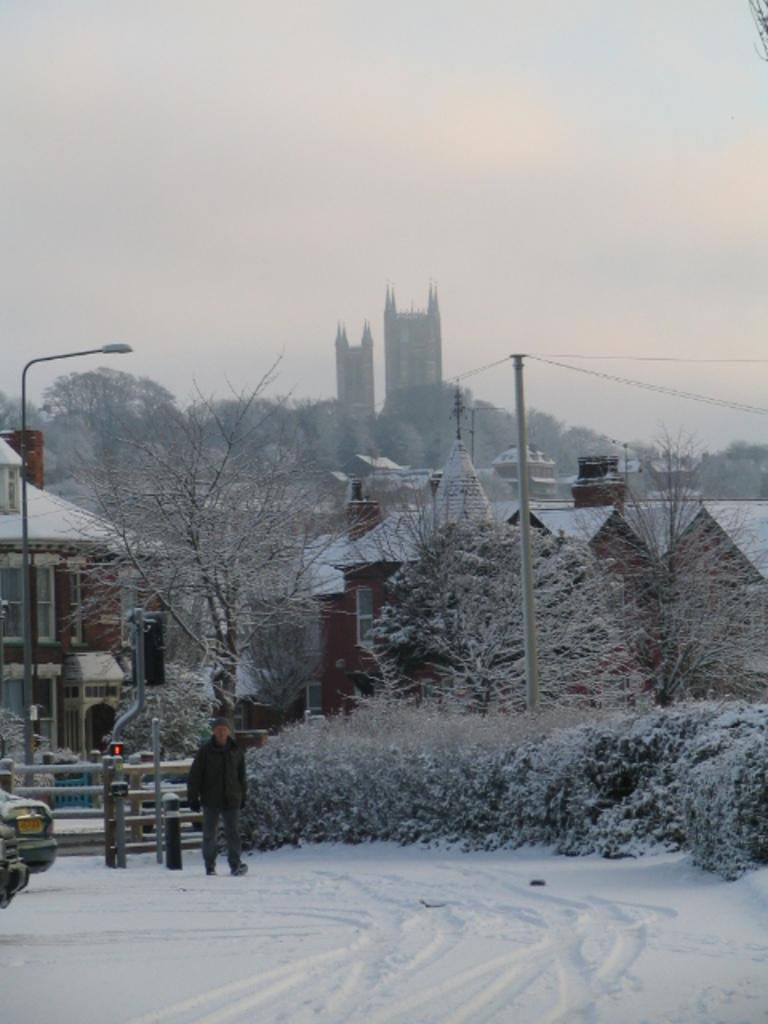What is the man in the image doing? The man is walking in the image. What is the weather like in the image? There is snow in the image, indicating a cold and wintry environment. What can be seen in the background of the image? There is a fence, plants, trees, a current pole, a street lamp, and buildings visible in the background. What is visible in the sky in the image? The sky is visible in the image. What type of cave can be seen in the image? There is no cave present in the image. What is the tendency of the sound in the image? There is no sound present in the image, so it is not possible to determine its tendency. 